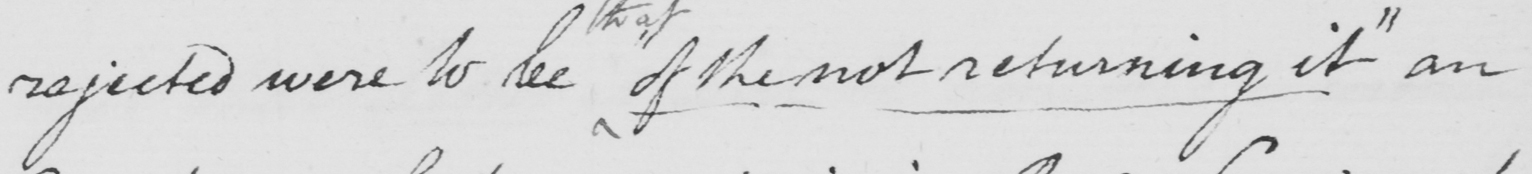What text is written in this handwritten line? rejected were to see of the not returning it "  an 